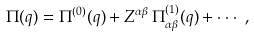<formula> <loc_0><loc_0><loc_500><loc_500>\Pi ( q ) = \Pi ^ { ( 0 ) } ( q ) + Z ^ { \alpha \beta } \, \Pi ^ { ( 1 ) } _ { \alpha \beta } ( q ) + \cdot \cdot \cdot \ ,</formula> 